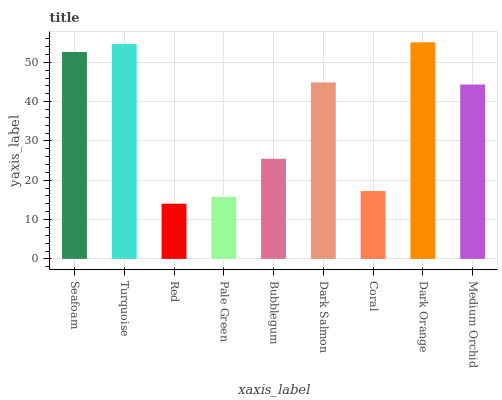Is Red the minimum?
Answer yes or no. Yes. Is Dark Orange the maximum?
Answer yes or no. Yes. Is Turquoise the minimum?
Answer yes or no. No. Is Turquoise the maximum?
Answer yes or no. No. Is Turquoise greater than Seafoam?
Answer yes or no. Yes. Is Seafoam less than Turquoise?
Answer yes or no. Yes. Is Seafoam greater than Turquoise?
Answer yes or no. No. Is Turquoise less than Seafoam?
Answer yes or no. No. Is Medium Orchid the high median?
Answer yes or no. Yes. Is Medium Orchid the low median?
Answer yes or no. Yes. Is Bubblegum the high median?
Answer yes or no. No. Is Turquoise the low median?
Answer yes or no. No. 